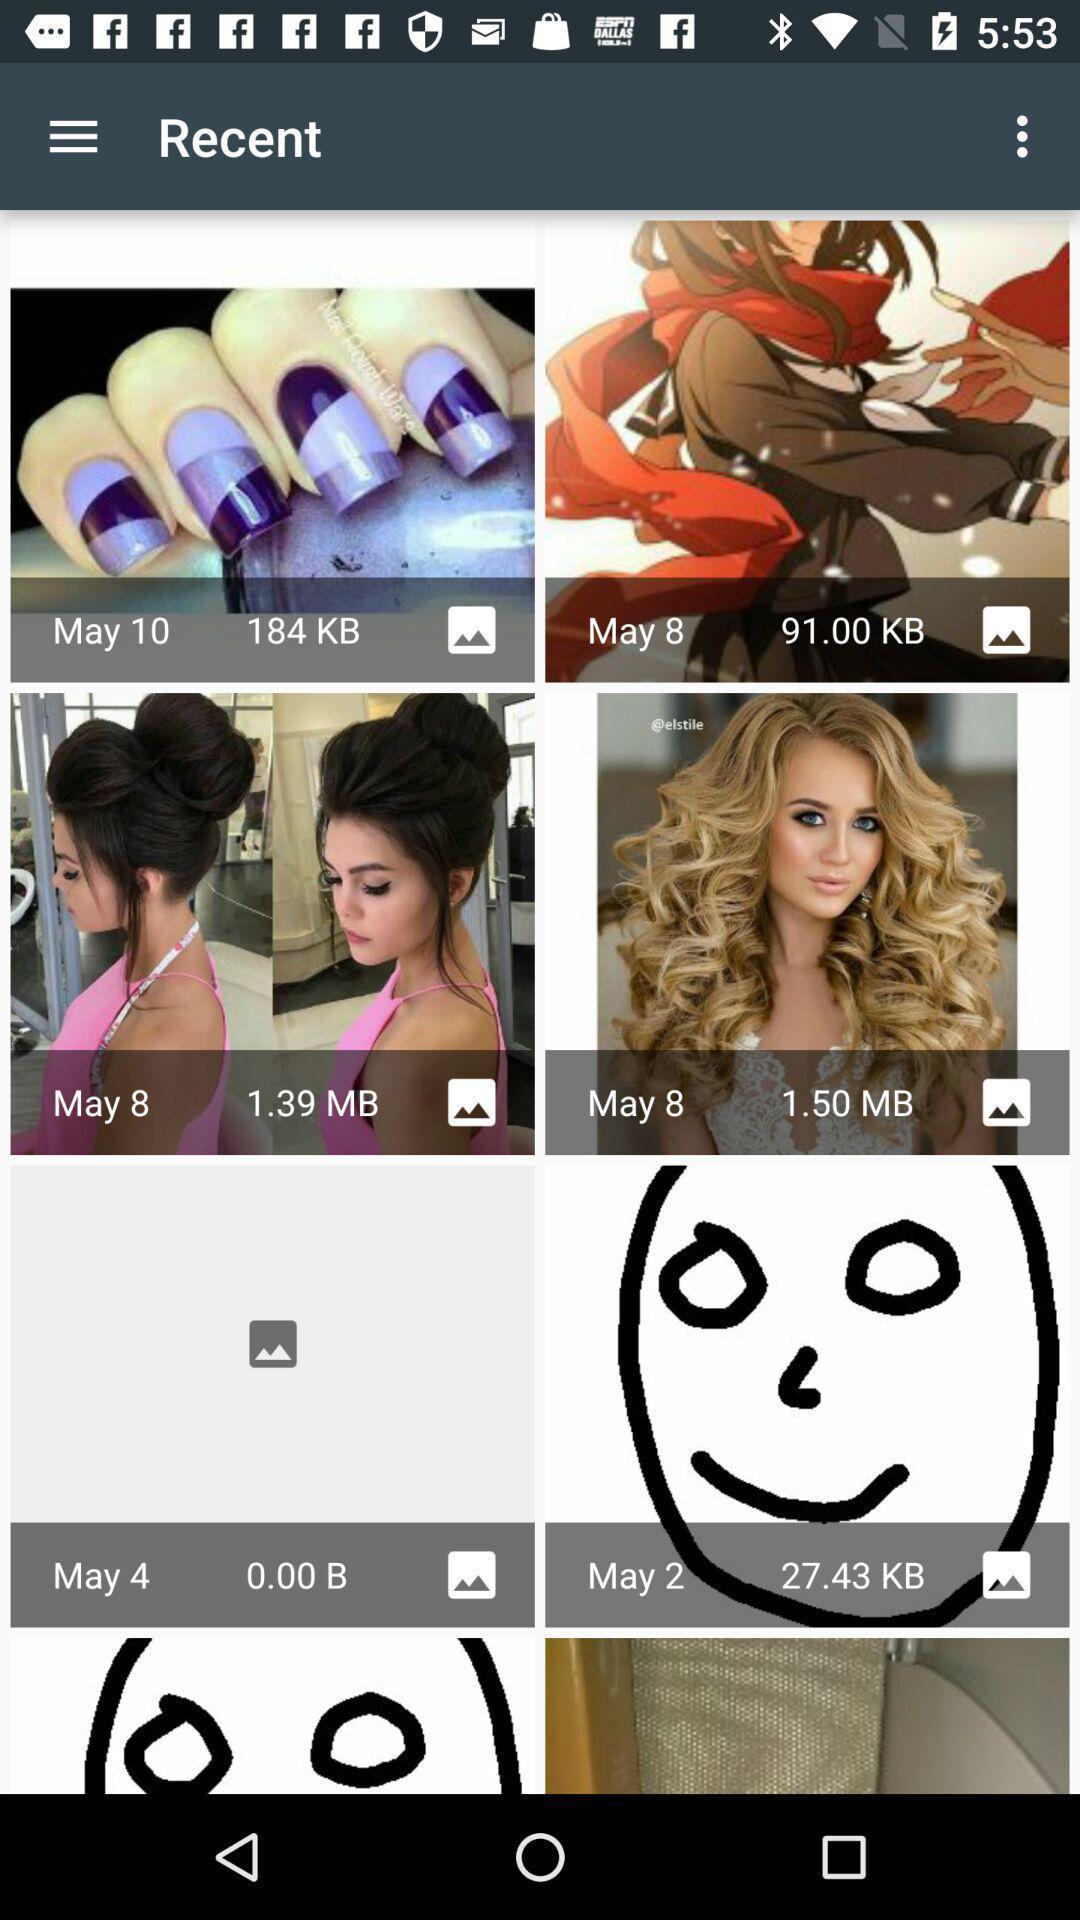What can you discern from this picture? Recent photos in the gallery app. 